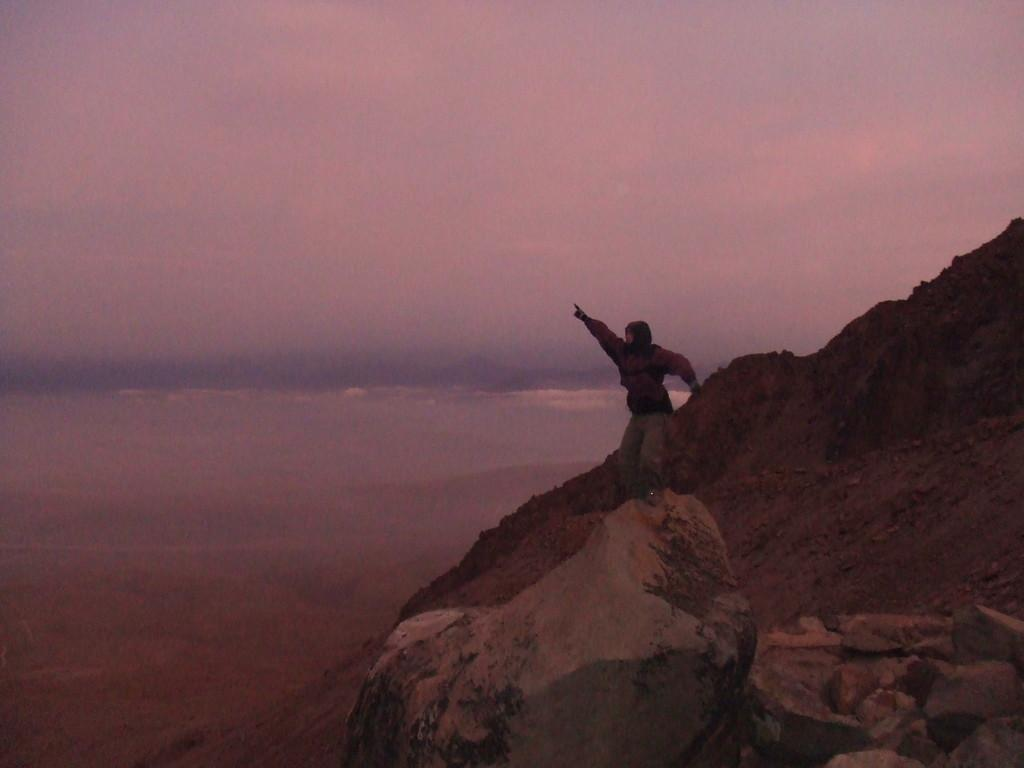What objects can be seen in the image? There are stones in the image. What is the person in the image doing? A person is standing on one of the stones. What can be seen in the background of the image? There are clouds and the sky visible in the background of the image. What type of grape is being used as a reward for the person standing on the stones? There is no grape present in the image, nor is there any indication of a reward being given. 